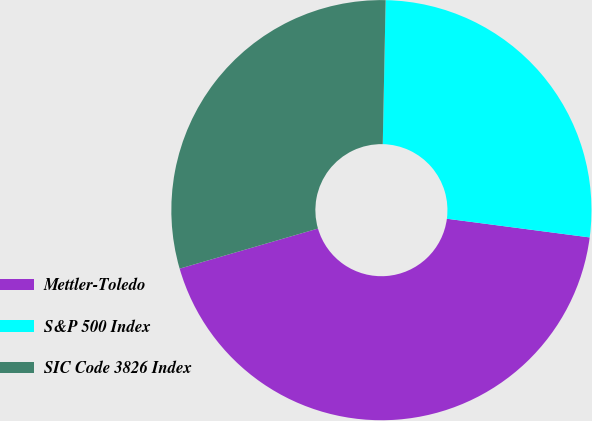Convert chart to OTSL. <chart><loc_0><loc_0><loc_500><loc_500><pie_chart><fcel>Mettler-Toledo<fcel>S&P 500 Index<fcel>SIC Code 3826 Index<nl><fcel>43.44%<fcel>26.75%<fcel>29.81%<nl></chart> 